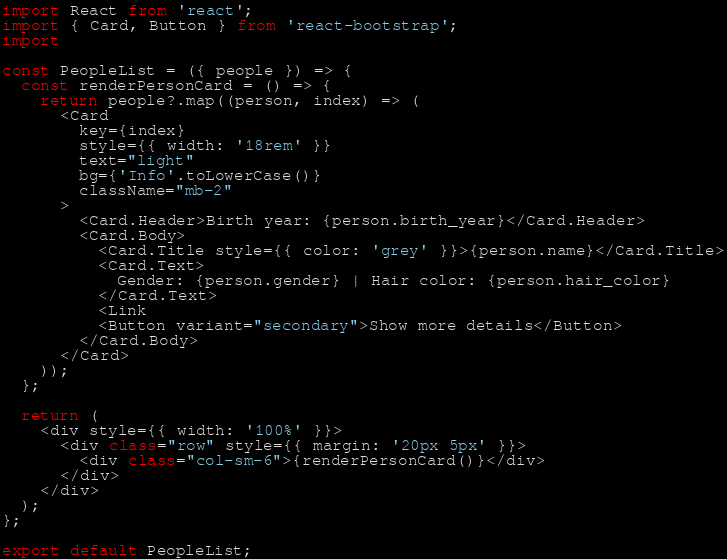<code> <loc_0><loc_0><loc_500><loc_500><_JavaScript_>import React from 'react';
import { Card, Button } from 'react-bootstrap';
import 

const PeopleList = ({ people }) => {
  const renderPersonCard = () => {
    return people?.map((person, index) => (
      <Card
        key={index}
        style={{ width: '18rem' }}
        text="light"
        bg={'Info'.toLowerCase()}
        className="mb-2"
      >
        <Card.Header>Birth year: {person.birth_year}</Card.Header>
        <Card.Body>
          <Card.Title style={{ color: 'grey' }}>{person.name}</Card.Title>
          <Card.Text>
            Gender: {person.gender} | Hair color: {person.hair_color}
          </Card.Text>
          <Link 
          <Button variant="secondary">Show more details</Button>
        </Card.Body>
      </Card>
    ));
  };

  return (
    <div style={{ width: '100%' }}>
      <div class="row" style={{ margin: '20px 5px' }}>
        <div class="col-sm-6">{renderPersonCard()}</div>
      </div>
    </div>
  );
};

export default PeopleList;
</code> 